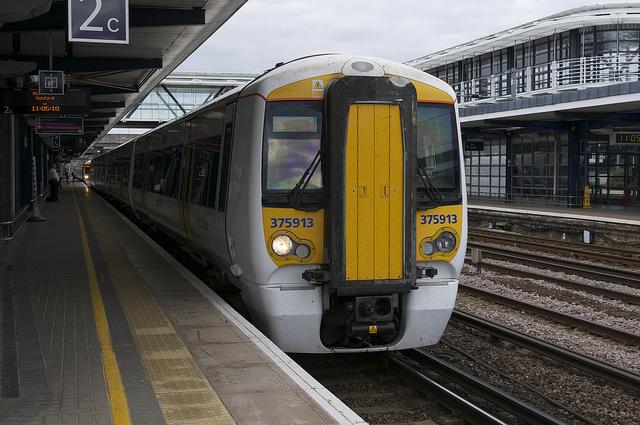What numbers are on the front of the bus?
Be succinct. 375913. What are the numbers on the train?
Write a very short answer. 375913. What color is the train?
Quick response, please. White and yellow. What is the platform number on the left?
Answer briefly. 2c. What stop is this?
Answer briefly. 2c. Could this train haul passengers?
Be succinct. Yes. 